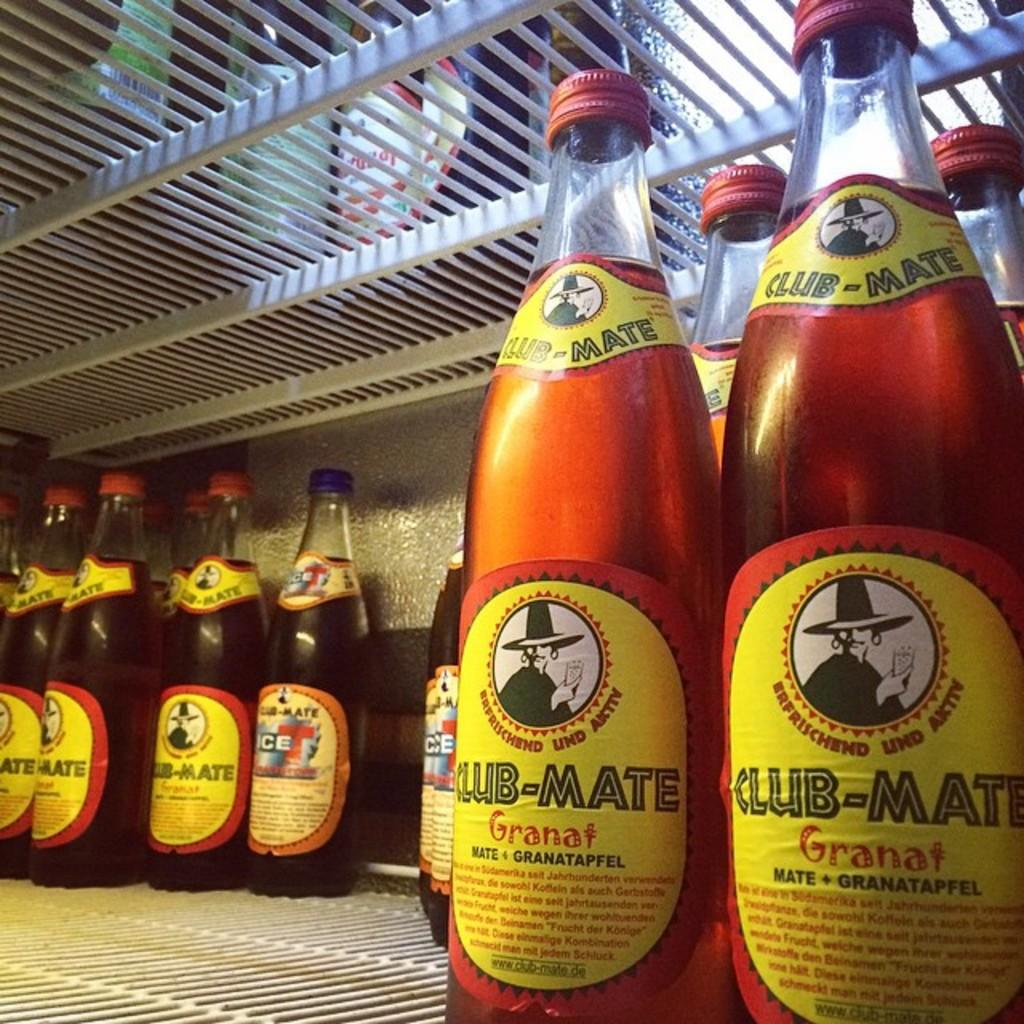What objects are present in the image? There are bottles in the image. How are the bottles arranged in the image? The bottles are in a rack. What type of sink is visible in the image? There is no sink present in the image; it only features bottles in a rack. 